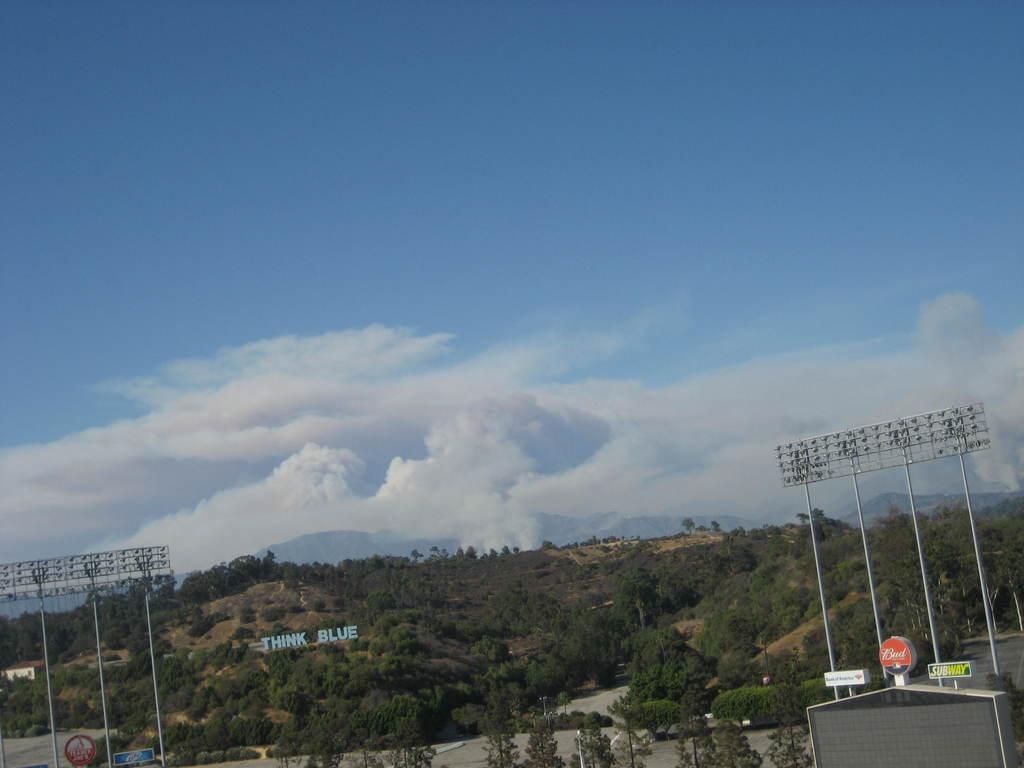Describe this image in one or two sentences. In the foreground of the picture there are flood lights, trees, hoardings and a nameplate. Sky is bit cloudy. In the center of the background there are mountains. 